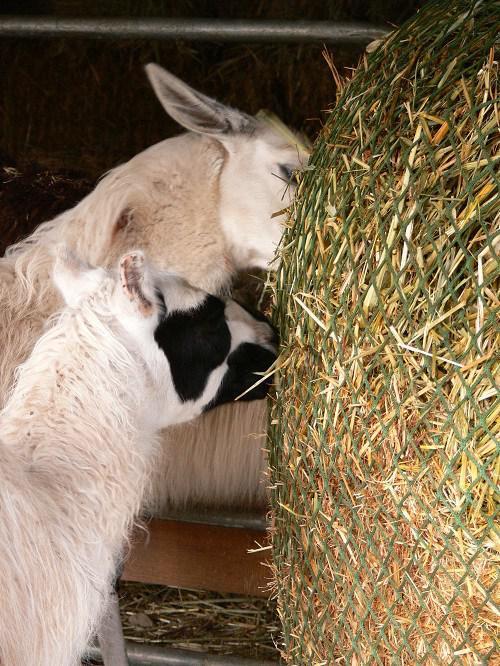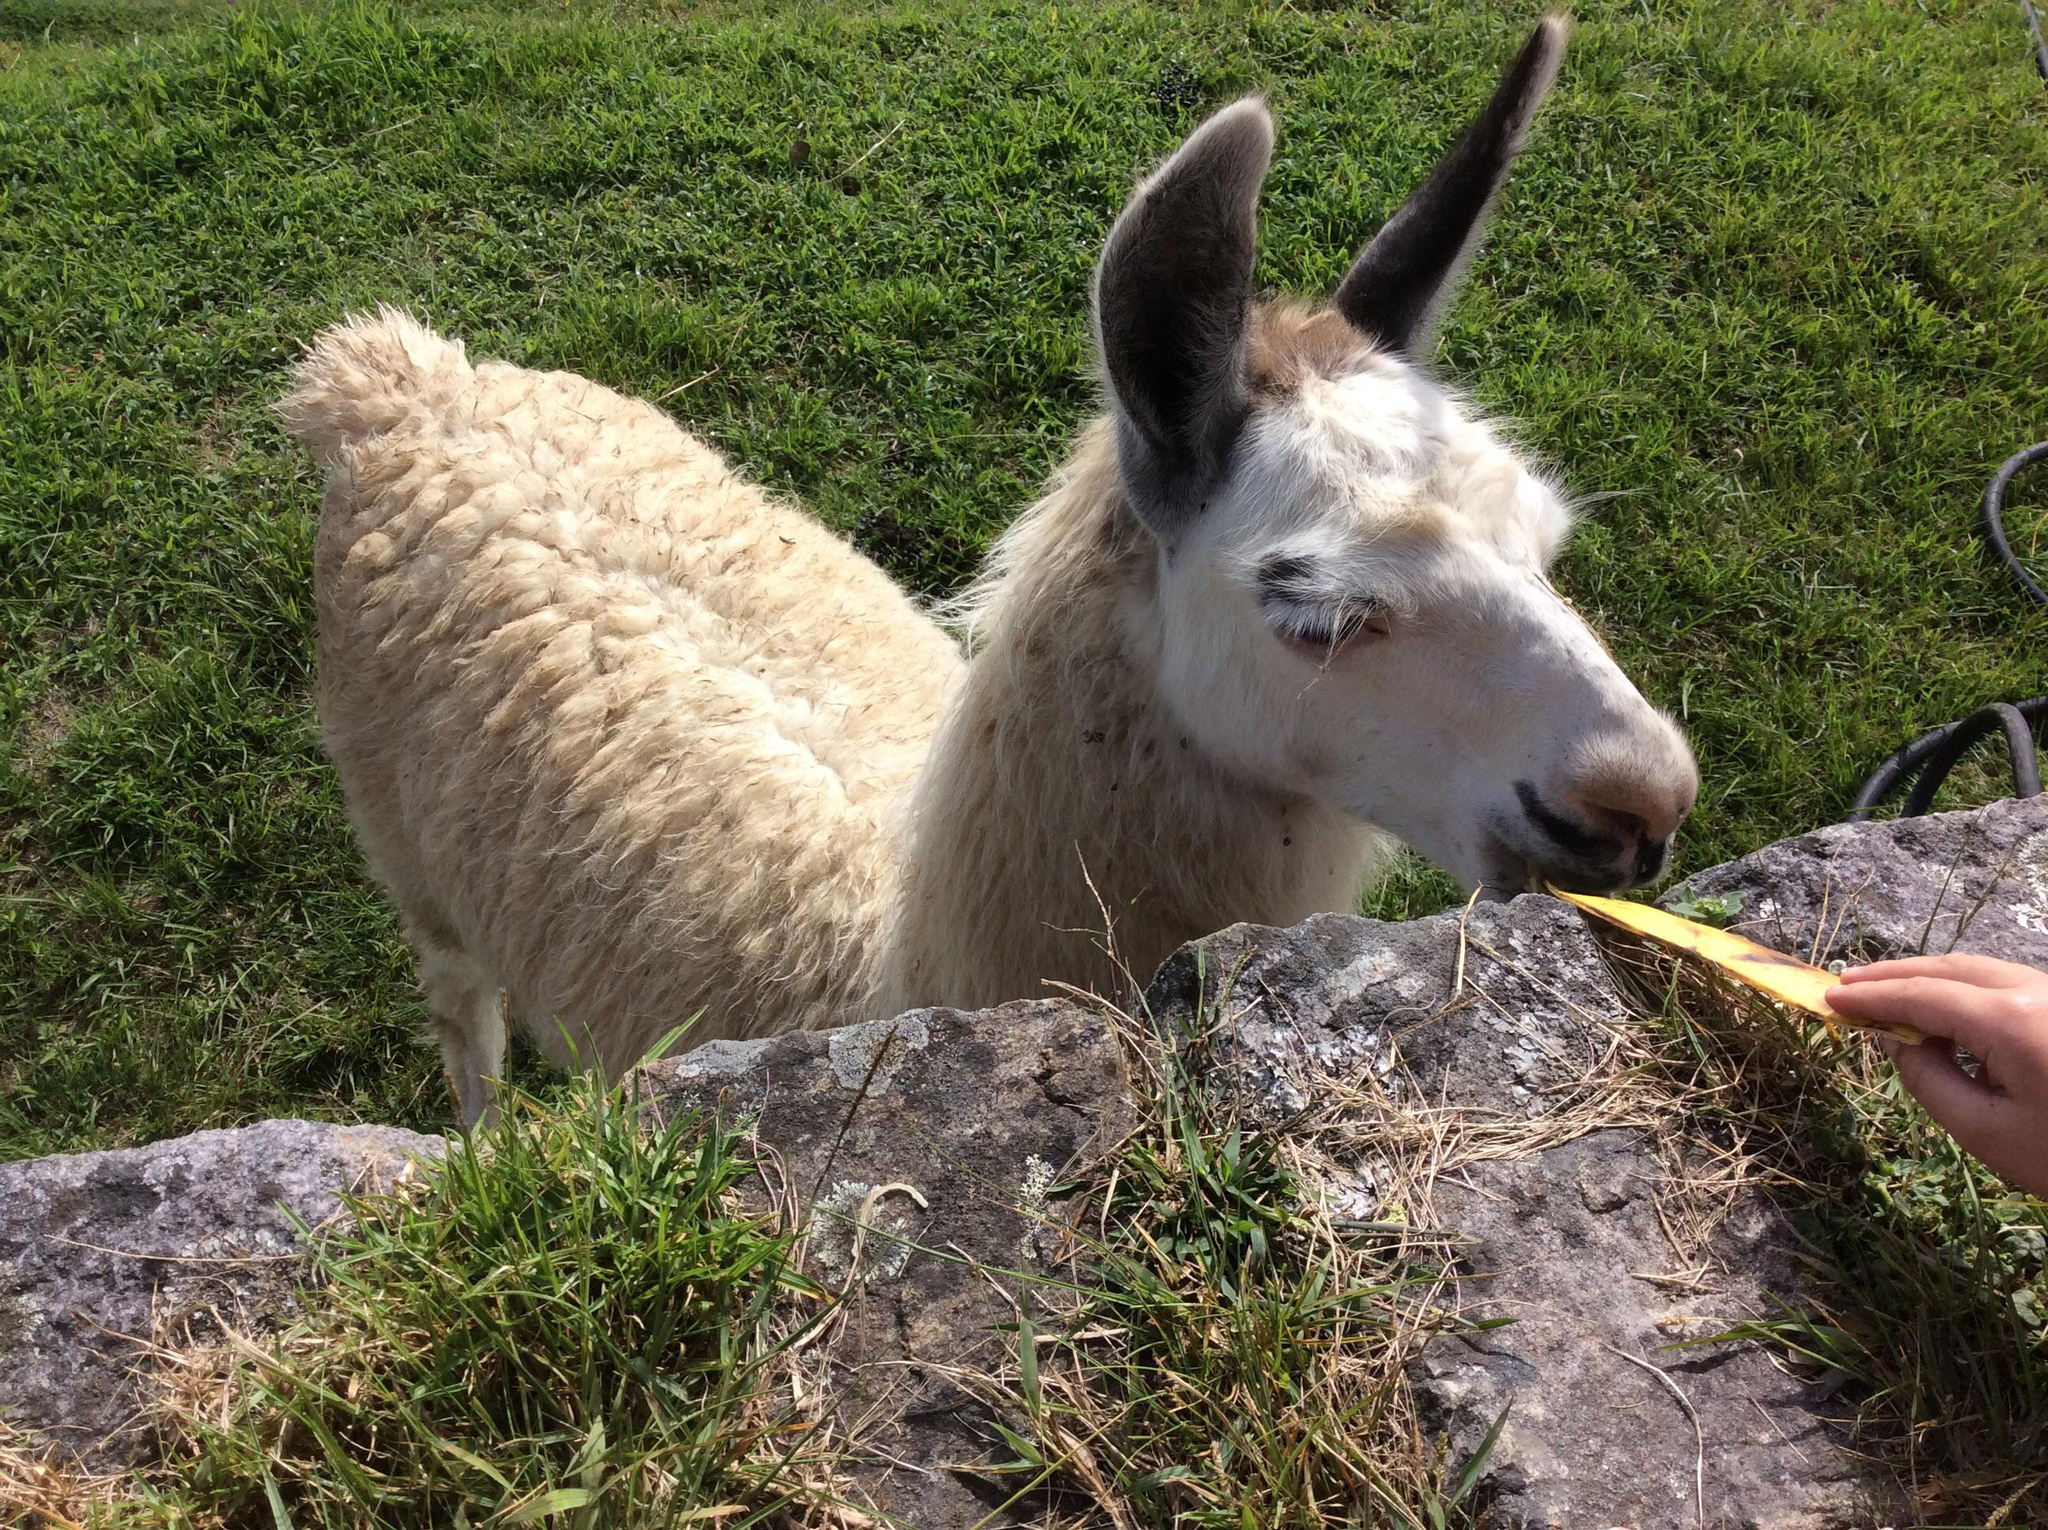The first image is the image on the left, the second image is the image on the right. Evaluate the accuracy of this statement regarding the images: "A human is feeding one of the llamas". Is it true? Answer yes or no. Yes. The first image is the image on the left, the second image is the image on the right. Assess this claim about the two images: "In at least one image there is a long necked animal facing forward left with greenery in its mouth.". Correct or not? Answer yes or no. No. 